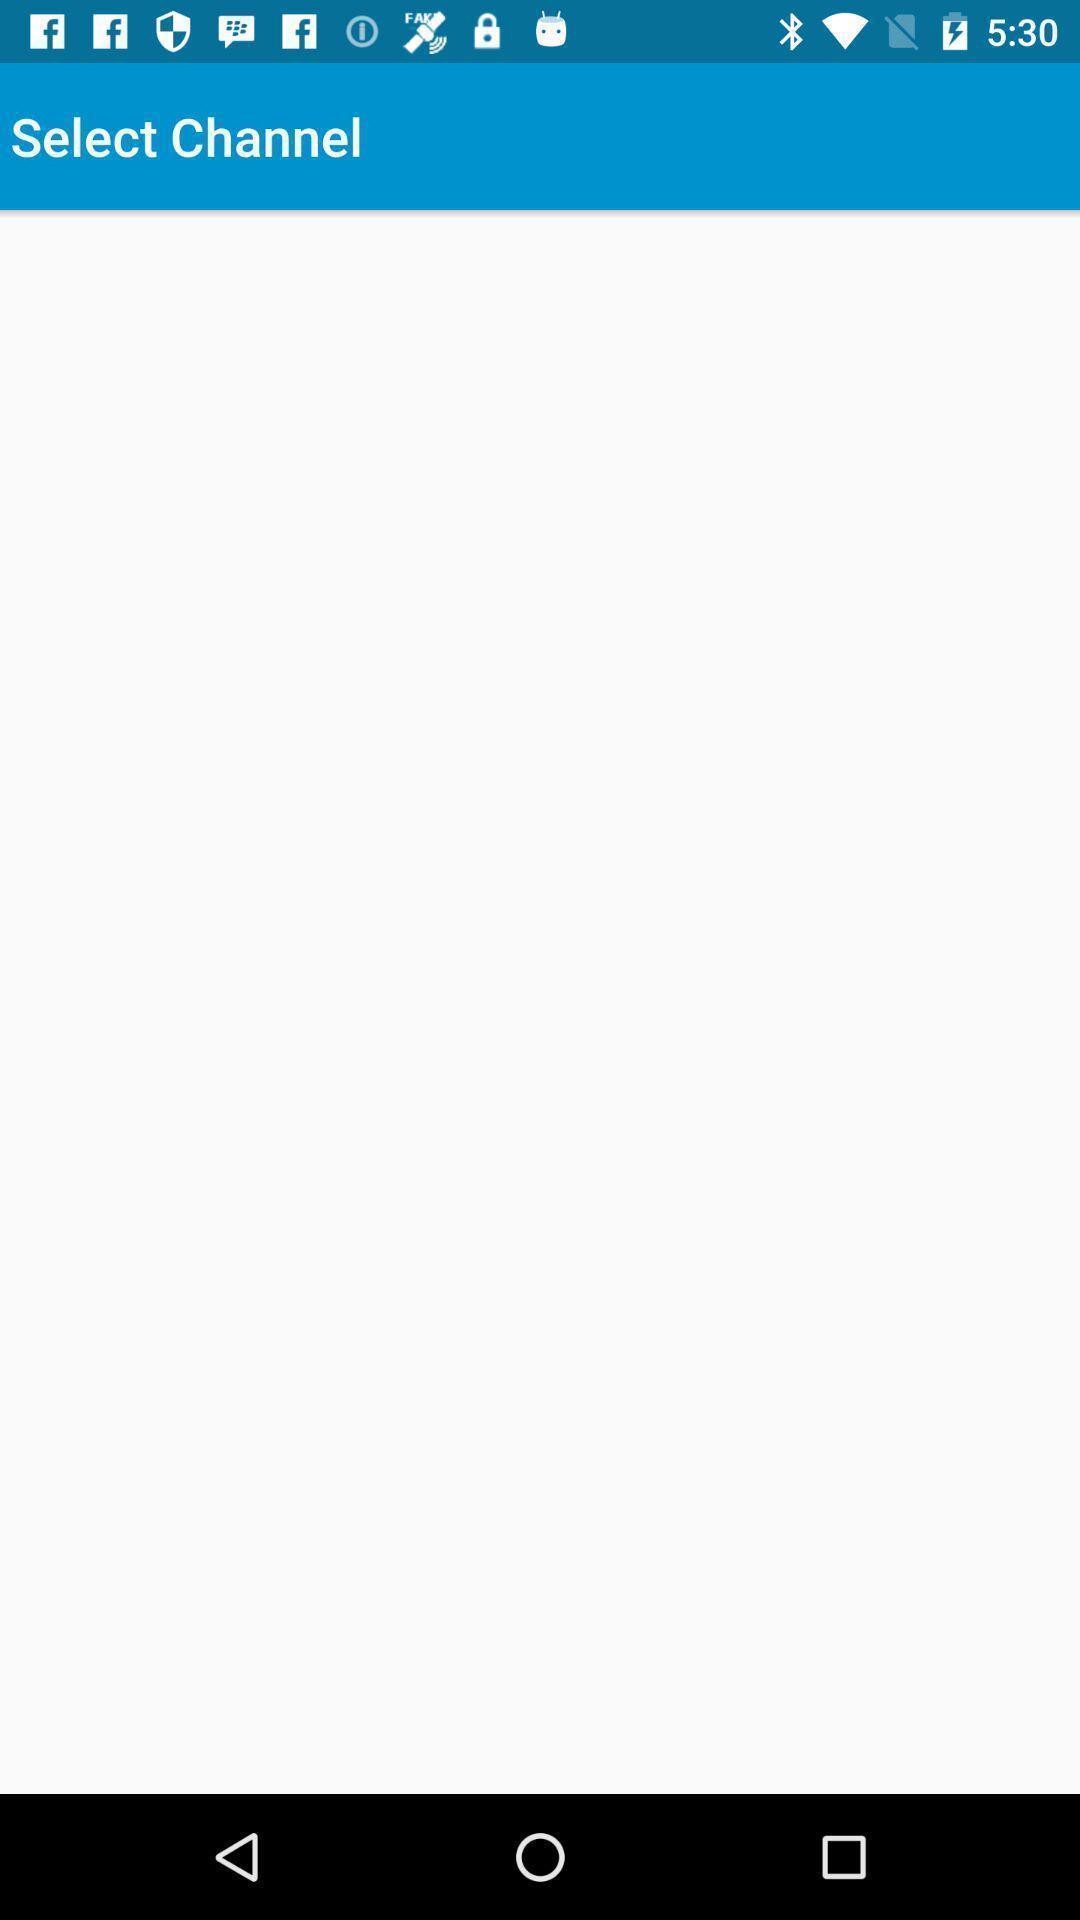Give me a summary of this screen capture. Select channel page of a service app. 